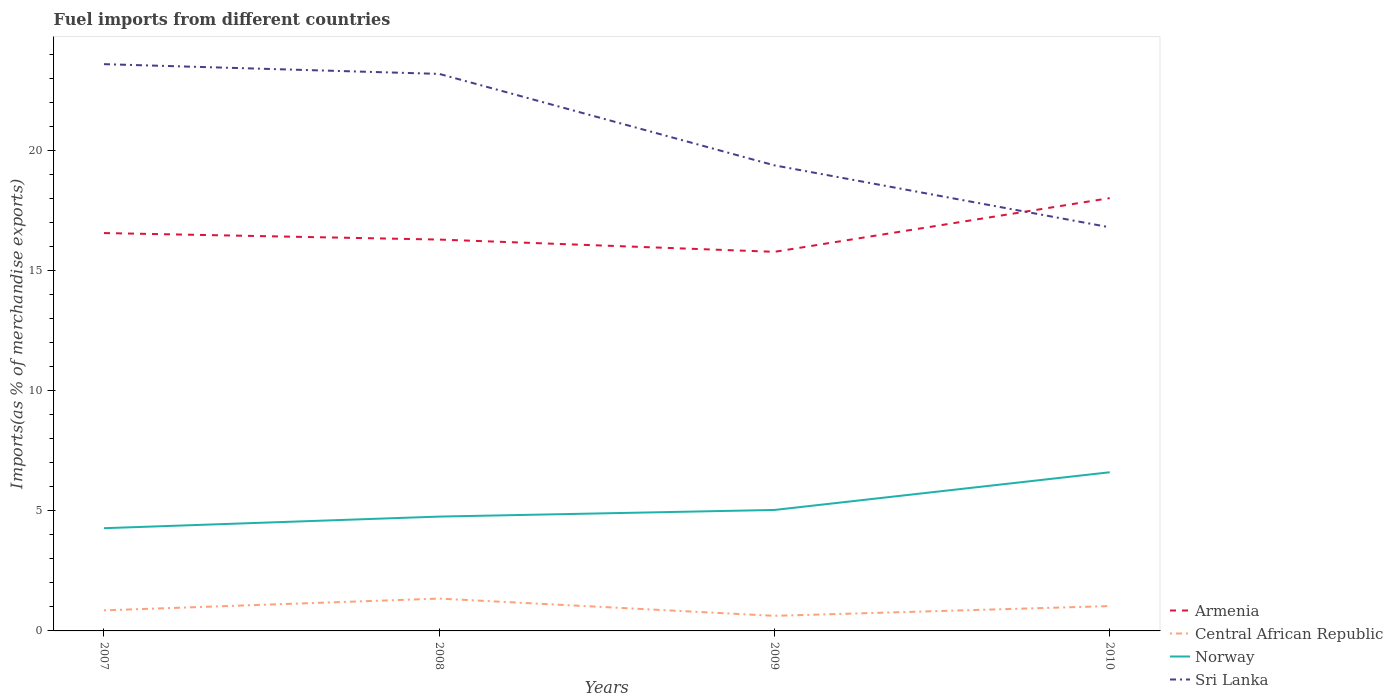Is the number of lines equal to the number of legend labels?
Make the answer very short. Yes. Across all years, what is the maximum percentage of imports to different countries in Central African Republic?
Ensure brevity in your answer.  0.63. In which year was the percentage of imports to different countries in Sri Lanka maximum?
Make the answer very short. 2010. What is the total percentage of imports to different countries in Norway in the graph?
Give a very brief answer. -0.48. What is the difference between the highest and the second highest percentage of imports to different countries in Armenia?
Keep it short and to the point. 2.24. What is the difference between the highest and the lowest percentage of imports to different countries in Armenia?
Make the answer very short. 1. Is the percentage of imports to different countries in Norway strictly greater than the percentage of imports to different countries in Armenia over the years?
Your answer should be very brief. Yes. How many lines are there?
Offer a terse response. 4. How many years are there in the graph?
Make the answer very short. 4. Where does the legend appear in the graph?
Your answer should be very brief. Bottom right. How many legend labels are there?
Provide a succinct answer. 4. What is the title of the graph?
Keep it short and to the point. Fuel imports from different countries. Does "Turkey" appear as one of the legend labels in the graph?
Offer a very short reply. No. What is the label or title of the X-axis?
Your answer should be compact. Years. What is the label or title of the Y-axis?
Your response must be concise. Imports(as % of merchandise exports). What is the Imports(as % of merchandise exports) in Armenia in 2007?
Your answer should be very brief. 16.57. What is the Imports(as % of merchandise exports) in Central African Republic in 2007?
Provide a short and direct response. 0.86. What is the Imports(as % of merchandise exports) of Norway in 2007?
Ensure brevity in your answer.  4.28. What is the Imports(as % of merchandise exports) in Sri Lanka in 2007?
Provide a short and direct response. 23.61. What is the Imports(as % of merchandise exports) of Armenia in 2008?
Provide a succinct answer. 16.3. What is the Imports(as % of merchandise exports) of Central African Republic in 2008?
Offer a very short reply. 1.35. What is the Imports(as % of merchandise exports) of Norway in 2008?
Your answer should be very brief. 4.76. What is the Imports(as % of merchandise exports) in Sri Lanka in 2008?
Offer a terse response. 23.2. What is the Imports(as % of merchandise exports) in Armenia in 2009?
Your answer should be compact. 15.79. What is the Imports(as % of merchandise exports) in Central African Republic in 2009?
Keep it short and to the point. 0.63. What is the Imports(as % of merchandise exports) in Norway in 2009?
Keep it short and to the point. 5.04. What is the Imports(as % of merchandise exports) of Sri Lanka in 2009?
Provide a short and direct response. 19.39. What is the Imports(as % of merchandise exports) in Armenia in 2010?
Provide a short and direct response. 18.03. What is the Imports(as % of merchandise exports) of Central African Republic in 2010?
Make the answer very short. 1.03. What is the Imports(as % of merchandise exports) in Norway in 2010?
Ensure brevity in your answer.  6.61. What is the Imports(as % of merchandise exports) of Sri Lanka in 2010?
Provide a succinct answer. 16.81. Across all years, what is the maximum Imports(as % of merchandise exports) of Armenia?
Provide a succinct answer. 18.03. Across all years, what is the maximum Imports(as % of merchandise exports) in Central African Republic?
Make the answer very short. 1.35. Across all years, what is the maximum Imports(as % of merchandise exports) of Norway?
Give a very brief answer. 6.61. Across all years, what is the maximum Imports(as % of merchandise exports) in Sri Lanka?
Give a very brief answer. 23.61. Across all years, what is the minimum Imports(as % of merchandise exports) of Armenia?
Your response must be concise. 15.79. Across all years, what is the minimum Imports(as % of merchandise exports) of Central African Republic?
Your answer should be very brief. 0.63. Across all years, what is the minimum Imports(as % of merchandise exports) in Norway?
Offer a terse response. 4.28. Across all years, what is the minimum Imports(as % of merchandise exports) of Sri Lanka?
Provide a short and direct response. 16.81. What is the total Imports(as % of merchandise exports) in Armenia in the graph?
Offer a terse response. 66.7. What is the total Imports(as % of merchandise exports) in Central African Republic in the graph?
Offer a terse response. 3.87. What is the total Imports(as % of merchandise exports) in Norway in the graph?
Your answer should be very brief. 20.69. What is the total Imports(as % of merchandise exports) of Sri Lanka in the graph?
Your answer should be compact. 83.02. What is the difference between the Imports(as % of merchandise exports) in Armenia in 2007 and that in 2008?
Provide a short and direct response. 0.27. What is the difference between the Imports(as % of merchandise exports) of Central African Republic in 2007 and that in 2008?
Offer a very short reply. -0.49. What is the difference between the Imports(as % of merchandise exports) in Norway in 2007 and that in 2008?
Make the answer very short. -0.48. What is the difference between the Imports(as % of merchandise exports) of Sri Lanka in 2007 and that in 2008?
Provide a short and direct response. 0.41. What is the difference between the Imports(as % of merchandise exports) of Armenia in 2007 and that in 2009?
Offer a very short reply. 0.78. What is the difference between the Imports(as % of merchandise exports) in Central African Republic in 2007 and that in 2009?
Make the answer very short. 0.23. What is the difference between the Imports(as % of merchandise exports) of Norway in 2007 and that in 2009?
Your answer should be compact. -0.76. What is the difference between the Imports(as % of merchandise exports) in Sri Lanka in 2007 and that in 2009?
Your response must be concise. 4.22. What is the difference between the Imports(as % of merchandise exports) in Armenia in 2007 and that in 2010?
Make the answer very short. -1.46. What is the difference between the Imports(as % of merchandise exports) of Central African Republic in 2007 and that in 2010?
Provide a succinct answer. -0.18. What is the difference between the Imports(as % of merchandise exports) of Norway in 2007 and that in 2010?
Give a very brief answer. -2.33. What is the difference between the Imports(as % of merchandise exports) in Sri Lanka in 2007 and that in 2010?
Offer a very short reply. 6.8. What is the difference between the Imports(as % of merchandise exports) of Armenia in 2008 and that in 2009?
Ensure brevity in your answer.  0.51. What is the difference between the Imports(as % of merchandise exports) in Central African Republic in 2008 and that in 2009?
Make the answer very short. 0.72. What is the difference between the Imports(as % of merchandise exports) of Norway in 2008 and that in 2009?
Offer a very short reply. -0.28. What is the difference between the Imports(as % of merchandise exports) of Sri Lanka in 2008 and that in 2009?
Ensure brevity in your answer.  3.81. What is the difference between the Imports(as % of merchandise exports) in Armenia in 2008 and that in 2010?
Your answer should be very brief. -1.73. What is the difference between the Imports(as % of merchandise exports) of Central African Republic in 2008 and that in 2010?
Provide a short and direct response. 0.31. What is the difference between the Imports(as % of merchandise exports) in Norway in 2008 and that in 2010?
Give a very brief answer. -1.85. What is the difference between the Imports(as % of merchandise exports) of Sri Lanka in 2008 and that in 2010?
Ensure brevity in your answer.  6.39. What is the difference between the Imports(as % of merchandise exports) of Armenia in 2009 and that in 2010?
Offer a very short reply. -2.24. What is the difference between the Imports(as % of merchandise exports) of Central African Republic in 2009 and that in 2010?
Ensure brevity in your answer.  -0.41. What is the difference between the Imports(as % of merchandise exports) in Norway in 2009 and that in 2010?
Your answer should be compact. -1.57. What is the difference between the Imports(as % of merchandise exports) in Sri Lanka in 2009 and that in 2010?
Keep it short and to the point. 2.58. What is the difference between the Imports(as % of merchandise exports) of Armenia in 2007 and the Imports(as % of merchandise exports) of Central African Republic in 2008?
Your response must be concise. 15.23. What is the difference between the Imports(as % of merchandise exports) of Armenia in 2007 and the Imports(as % of merchandise exports) of Norway in 2008?
Ensure brevity in your answer.  11.81. What is the difference between the Imports(as % of merchandise exports) of Armenia in 2007 and the Imports(as % of merchandise exports) of Sri Lanka in 2008?
Your answer should be compact. -6.63. What is the difference between the Imports(as % of merchandise exports) in Central African Republic in 2007 and the Imports(as % of merchandise exports) in Norway in 2008?
Provide a short and direct response. -3.91. What is the difference between the Imports(as % of merchandise exports) in Central African Republic in 2007 and the Imports(as % of merchandise exports) in Sri Lanka in 2008?
Make the answer very short. -22.35. What is the difference between the Imports(as % of merchandise exports) in Norway in 2007 and the Imports(as % of merchandise exports) in Sri Lanka in 2008?
Provide a short and direct response. -18.92. What is the difference between the Imports(as % of merchandise exports) in Armenia in 2007 and the Imports(as % of merchandise exports) in Central African Republic in 2009?
Keep it short and to the point. 15.95. What is the difference between the Imports(as % of merchandise exports) in Armenia in 2007 and the Imports(as % of merchandise exports) in Norway in 2009?
Offer a terse response. 11.53. What is the difference between the Imports(as % of merchandise exports) in Armenia in 2007 and the Imports(as % of merchandise exports) in Sri Lanka in 2009?
Provide a short and direct response. -2.82. What is the difference between the Imports(as % of merchandise exports) of Central African Republic in 2007 and the Imports(as % of merchandise exports) of Norway in 2009?
Your answer should be very brief. -4.18. What is the difference between the Imports(as % of merchandise exports) of Central African Republic in 2007 and the Imports(as % of merchandise exports) of Sri Lanka in 2009?
Keep it short and to the point. -18.54. What is the difference between the Imports(as % of merchandise exports) in Norway in 2007 and the Imports(as % of merchandise exports) in Sri Lanka in 2009?
Your response must be concise. -15.11. What is the difference between the Imports(as % of merchandise exports) of Armenia in 2007 and the Imports(as % of merchandise exports) of Central African Republic in 2010?
Provide a short and direct response. 15.54. What is the difference between the Imports(as % of merchandise exports) in Armenia in 2007 and the Imports(as % of merchandise exports) in Norway in 2010?
Make the answer very short. 9.96. What is the difference between the Imports(as % of merchandise exports) of Armenia in 2007 and the Imports(as % of merchandise exports) of Sri Lanka in 2010?
Offer a terse response. -0.24. What is the difference between the Imports(as % of merchandise exports) in Central African Republic in 2007 and the Imports(as % of merchandise exports) in Norway in 2010?
Offer a terse response. -5.75. What is the difference between the Imports(as % of merchandise exports) in Central African Republic in 2007 and the Imports(as % of merchandise exports) in Sri Lanka in 2010?
Your answer should be very brief. -15.96. What is the difference between the Imports(as % of merchandise exports) of Norway in 2007 and the Imports(as % of merchandise exports) of Sri Lanka in 2010?
Ensure brevity in your answer.  -12.53. What is the difference between the Imports(as % of merchandise exports) of Armenia in 2008 and the Imports(as % of merchandise exports) of Central African Republic in 2009?
Your answer should be very brief. 15.67. What is the difference between the Imports(as % of merchandise exports) of Armenia in 2008 and the Imports(as % of merchandise exports) of Norway in 2009?
Offer a very short reply. 11.26. What is the difference between the Imports(as % of merchandise exports) in Armenia in 2008 and the Imports(as % of merchandise exports) in Sri Lanka in 2009?
Keep it short and to the point. -3.09. What is the difference between the Imports(as % of merchandise exports) in Central African Republic in 2008 and the Imports(as % of merchandise exports) in Norway in 2009?
Keep it short and to the point. -3.69. What is the difference between the Imports(as % of merchandise exports) in Central African Republic in 2008 and the Imports(as % of merchandise exports) in Sri Lanka in 2009?
Provide a short and direct response. -18.05. What is the difference between the Imports(as % of merchandise exports) in Norway in 2008 and the Imports(as % of merchandise exports) in Sri Lanka in 2009?
Your response must be concise. -14.63. What is the difference between the Imports(as % of merchandise exports) in Armenia in 2008 and the Imports(as % of merchandise exports) in Central African Republic in 2010?
Your answer should be compact. 15.27. What is the difference between the Imports(as % of merchandise exports) of Armenia in 2008 and the Imports(as % of merchandise exports) of Norway in 2010?
Your answer should be very brief. 9.69. What is the difference between the Imports(as % of merchandise exports) in Armenia in 2008 and the Imports(as % of merchandise exports) in Sri Lanka in 2010?
Provide a short and direct response. -0.51. What is the difference between the Imports(as % of merchandise exports) of Central African Republic in 2008 and the Imports(as % of merchandise exports) of Norway in 2010?
Ensure brevity in your answer.  -5.26. What is the difference between the Imports(as % of merchandise exports) in Central African Republic in 2008 and the Imports(as % of merchandise exports) in Sri Lanka in 2010?
Your response must be concise. -15.47. What is the difference between the Imports(as % of merchandise exports) in Norway in 2008 and the Imports(as % of merchandise exports) in Sri Lanka in 2010?
Provide a short and direct response. -12.05. What is the difference between the Imports(as % of merchandise exports) of Armenia in 2009 and the Imports(as % of merchandise exports) of Central African Republic in 2010?
Ensure brevity in your answer.  14.76. What is the difference between the Imports(as % of merchandise exports) of Armenia in 2009 and the Imports(as % of merchandise exports) of Norway in 2010?
Make the answer very short. 9.18. What is the difference between the Imports(as % of merchandise exports) of Armenia in 2009 and the Imports(as % of merchandise exports) of Sri Lanka in 2010?
Give a very brief answer. -1.02. What is the difference between the Imports(as % of merchandise exports) in Central African Republic in 2009 and the Imports(as % of merchandise exports) in Norway in 2010?
Provide a short and direct response. -5.98. What is the difference between the Imports(as % of merchandise exports) of Central African Republic in 2009 and the Imports(as % of merchandise exports) of Sri Lanka in 2010?
Make the answer very short. -16.18. What is the difference between the Imports(as % of merchandise exports) in Norway in 2009 and the Imports(as % of merchandise exports) in Sri Lanka in 2010?
Keep it short and to the point. -11.77. What is the average Imports(as % of merchandise exports) of Armenia per year?
Your answer should be very brief. 16.67. What is the average Imports(as % of merchandise exports) in Central African Republic per year?
Your response must be concise. 0.97. What is the average Imports(as % of merchandise exports) of Norway per year?
Make the answer very short. 5.17. What is the average Imports(as % of merchandise exports) in Sri Lanka per year?
Your answer should be very brief. 20.75. In the year 2007, what is the difference between the Imports(as % of merchandise exports) in Armenia and Imports(as % of merchandise exports) in Central African Republic?
Offer a very short reply. 15.72. In the year 2007, what is the difference between the Imports(as % of merchandise exports) of Armenia and Imports(as % of merchandise exports) of Norway?
Give a very brief answer. 12.29. In the year 2007, what is the difference between the Imports(as % of merchandise exports) of Armenia and Imports(as % of merchandise exports) of Sri Lanka?
Provide a short and direct response. -7.04. In the year 2007, what is the difference between the Imports(as % of merchandise exports) of Central African Republic and Imports(as % of merchandise exports) of Norway?
Provide a succinct answer. -3.42. In the year 2007, what is the difference between the Imports(as % of merchandise exports) in Central African Republic and Imports(as % of merchandise exports) in Sri Lanka?
Make the answer very short. -22.75. In the year 2007, what is the difference between the Imports(as % of merchandise exports) of Norway and Imports(as % of merchandise exports) of Sri Lanka?
Make the answer very short. -19.33. In the year 2008, what is the difference between the Imports(as % of merchandise exports) of Armenia and Imports(as % of merchandise exports) of Central African Republic?
Offer a very short reply. 14.95. In the year 2008, what is the difference between the Imports(as % of merchandise exports) in Armenia and Imports(as % of merchandise exports) in Norway?
Provide a succinct answer. 11.54. In the year 2008, what is the difference between the Imports(as % of merchandise exports) in Armenia and Imports(as % of merchandise exports) in Sri Lanka?
Your response must be concise. -6.9. In the year 2008, what is the difference between the Imports(as % of merchandise exports) of Central African Republic and Imports(as % of merchandise exports) of Norway?
Your answer should be very brief. -3.42. In the year 2008, what is the difference between the Imports(as % of merchandise exports) in Central African Republic and Imports(as % of merchandise exports) in Sri Lanka?
Keep it short and to the point. -21.86. In the year 2008, what is the difference between the Imports(as % of merchandise exports) in Norway and Imports(as % of merchandise exports) in Sri Lanka?
Give a very brief answer. -18.44. In the year 2009, what is the difference between the Imports(as % of merchandise exports) of Armenia and Imports(as % of merchandise exports) of Central African Republic?
Give a very brief answer. 15.16. In the year 2009, what is the difference between the Imports(as % of merchandise exports) in Armenia and Imports(as % of merchandise exports) in Norway?
Keep it short and to the point. 10.75. In the year 2009, what is the difference between the Imports(as % of merchandise exports) in Armenia and Imports(as % of merchandise exports) in Sri Lanka?
Make the answer very short. -3.6. In the year 2009, what is the difference between the Imports(as % of merchandise exports) of Central African Republic and Imports(as % of merchandise exports) of Norway?
Your answer should be very brief. -4.41. In the year 2009, what is the difference between the Imports(as % of merchandise exports) in Central African Republic and Imports(as % of merchandise exports) in Sri Lanka?
Offer a terse response. -18.76. In the year 2009, what is the difference between the Imports(as % of merchandise exports) of Norway and Imports(as % of merchandise exports) of Sri Lanka?
Offer a terse response. -14.35. In the year 2010, what is the difference between the Imports(as % of merchandise exports) of Armenia and Imports(as % of merchandise exports) of Central African Republic?
Keep it short and to the point. 16.99. In the year 2010, what is the difference between the Imports(as % of merchandise exports) in Armenia and Imports(as % of merchandise exports) in Norway?
Give a very brief answer. 11.42. In the year 2010, what is the difference between the Imports(as % of merchandise exports) in Armenia and Imports(as % of merchandise exports) in Sri Lanka?
Provide a succinct answer. 1.22. In the year 2010, what is the difference between the Imports(as % of merchandise exports) in Central African Republic and Imports(as % of merchandise exports) in Norway?
Ensure brevity in your answer.  -5.57. In the year 2010, what is the difference between the Imports(as % of merchandise exports) in Central African Republic and Imports(as % of merchandise exports) in Sri Lanka?
Ensure brevity in your answer.  -15.78. In the year 2010, what is the difference between the Imports(as % of merchandise exports) of Norway and Imports(as % of merchandise exports) of Sri Lanka?
Offer a very short reply. -10.2. What is the ratio of the Imports(as % of merchandise exports) of Armenia in 2007 to that in 2008?
Your response must be concise. 1.02. What is the ratio of the Imports(as % of merchandise exports) in Central African Republic in 2007 to that in 2008?
Your response must be concise. 0.64. What is the ratio of the Imports(as % of merchandise exports) of Norway in 2007 to that in 2008?
Offer a very short reply. 0.9. What is the ratio of the Imports(as % of merchandise exports) of Sri Lanka in 2007 to that in 2008?
Provide a succinct answer. 1.02. What is the ratio of the Imports(as % of merchandise exports) of Armenia in 2007 to that in 2009?
Ensure brevity in your answer.  1.05. What is the ratio of the Imports(as % of merchandise exports) of Central African Republic in 2007 to that in 2009?
Provide a short and direct response. 1.36. What is the ratio of the Imports(as % of merchandise exports) of Norway in 2007 to that in 2009?
Provide a succinct answer. 0.85. What is the ratio of the Imports(as % of merchandise exports) of Sri Lanka in 2007 to that in 2009?
Make the answer very short. 1.22. What is the ratio of the Imports(as % of merchandise exports) in Armenia in 2007 to that in 2010?
Make the answer very short. 0.92. What is the ratio of the Imports(as % of merchandise exports) in Central African Republic in 2007 to that in 2010?
Your answer should be very brief. 0.83. What is the ratio of the Imports(as % of merchandise exports) in Norway in 2007 to that in 2010?
Your answer should be compact. 0.65. What is the ratio of the Imports(as % of merchandise exports) of Sri Lanka in 2007 to that in 2010?
Offer a very short reply. 1.4. What is the ratio of the Imports(as % of merchandise exports) of Armenia in 2008 to that in 2009?
Give a very brief answer. 1.03. What is the ratio of the Imports(as % of merchandise exports) of Central African Republic in 2008 to that in 2009?
Ensure brevity in your answer.  2.14. What is the ratio of the Imports(as % of merchandise exports) in Norway in 2008 to that in 2009?
Your answer should be compact. 0.95. What is the ratio of the Imports(as % of merchandise exports) of Sri Lanka in 2008 to that in 2009?
Make the answer very short. 1.2. What is the ratio of the Imports(as % of merchandise exports) of Armenia in 2008 to that in 2010?
Offer a terse response. 0.9. What is the ratio of the Imports(as % of merchandise exports) in Central African Republic in 2008 to that in 2010?
Your response must be concise. 1.3. What is the ratio of the Imports(as % of merchandise exports) of Norway in 2008 to that in 2010?
Make the answer very short. 0.72. What is the ratio of the Imports(as % of merchandise exports) of Sri Lanka in 2008 to that in 2010?
Provide a short and direct response. 1.38. What is the ratio of the Imports(as % of merchandise exports) in Armenia in 2009 to that in 2010?
Give a very brief answer. 0.88. What is the ratio of the Imports(as % of merchandise exports) of Central African Republic in 2009 to that in 2010?
Give a very brief answer. 0.61. What is the ratio of the Imports(as % of merchandise exports) in Norway in 2009 to that in 2010?
Make the answer very short. 0.76. What is the ratio of the Imports(as % of merchandise exports) in Sri Lanka in 2009 to that in 2010?
Your answer should be very brief. 1.15. What is the difference between the highest and the second highest Imports(as % of merchandise exports) of Armenia?
Your answer should be compact. 1.46. What is the difference between the highest and the second highest Imports(as % of merchandise exports) in Central African Republic?
Your answer should be very brief. 0.31. What is the difference between the highest and the second highest Imports(as % of merchandise exports) in Norway?
Your response must be concise. 1.57. What is the difference between the highest and the second highest Imports(as % of merchandise exports) of Sri Lanka?
Ensure brevity in your answer.  0.41. What is the difference between the highest and the lowest Imports(as % of merchandise exports) of Armenia?
Provide a short and direct response. 2.24. What is the difference between the highest and the lowest Imports(as % of merchandise exports) of Central African Republic?
Provide a succinct answer. 0.72. What is the difference between the highest and the lowest Imports(as % of merchandise exports) of Norway?
Provide a short and direct response. 2.33. What is the difference between the highest and the lowest Imports(as % of merchandise exports) of Sri Lanka?
Keep it short and to the point. 6.8. 